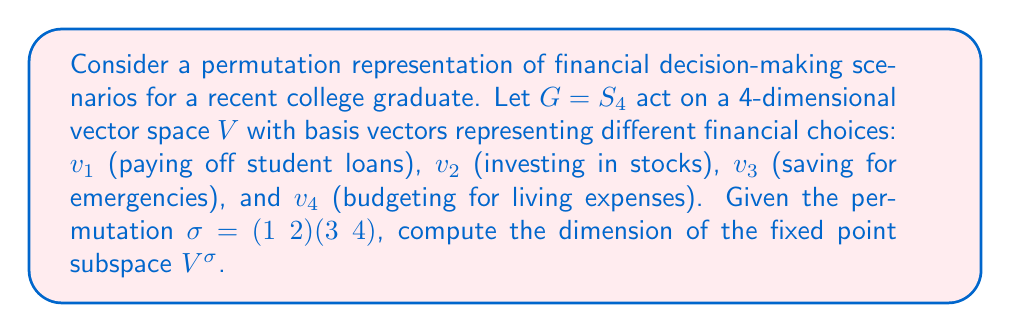Can you answer this question? To find the dimension of the fixed point subspace $V^\sigma$, we follow these steps:

1) First, recall that for a permutation representation, the dimension of the fixed point subspace is equal to the number of cycles in the permutation, including 1-cycles.

2) Let's analyze the given permutation $\sigma = (1 2)(3 4)$:
   - It consists of two 2-cycles: (1 2) and (3 4)
   - There are no 1-cycles (fixed points)

3) The number of cycles in $\sigma$ is 2.

4) Therefore, the dimension of the fixed point subspace $V^\sigma$ is 2.

5) Interpreting this result:
   - The fixed point subspace represents linear combinations of financial decisions that remain unchanged under the permutation.
   - In this case, it suggests that there are two independent ways to make financial decisions that are invariant under the given permutation.
   - For example, one basis vector of $V^\sigma$ could be $v_1 + v_2$ (balancing loan payments and investments), and another could be $v_3 + v_4$ (balancing savings and living expenses).

Thus, the dimension of the fixed point subspace $V^\sigma$ is 2, reflecting two independent financial strategies that remain stable under the given permutation of scenarios.
Answer: 2 